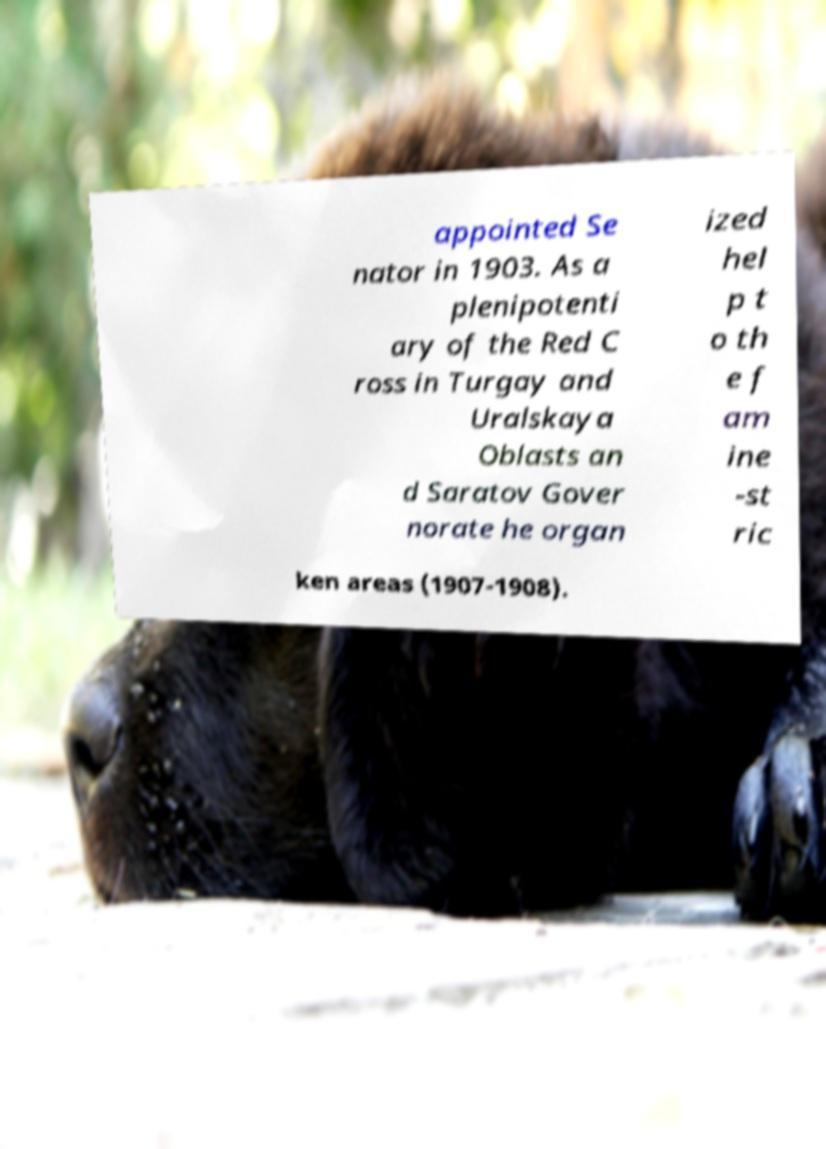Could you extract and type out the text from this image? appointed Se nator in 1903. As a plenipotenti ary of the Red C ross in Turgay and Uralskaya Oblasts an d Saratov Gover norate he organ ized hel p t o th e f am ine -st ric ken areas (1907-1908). 